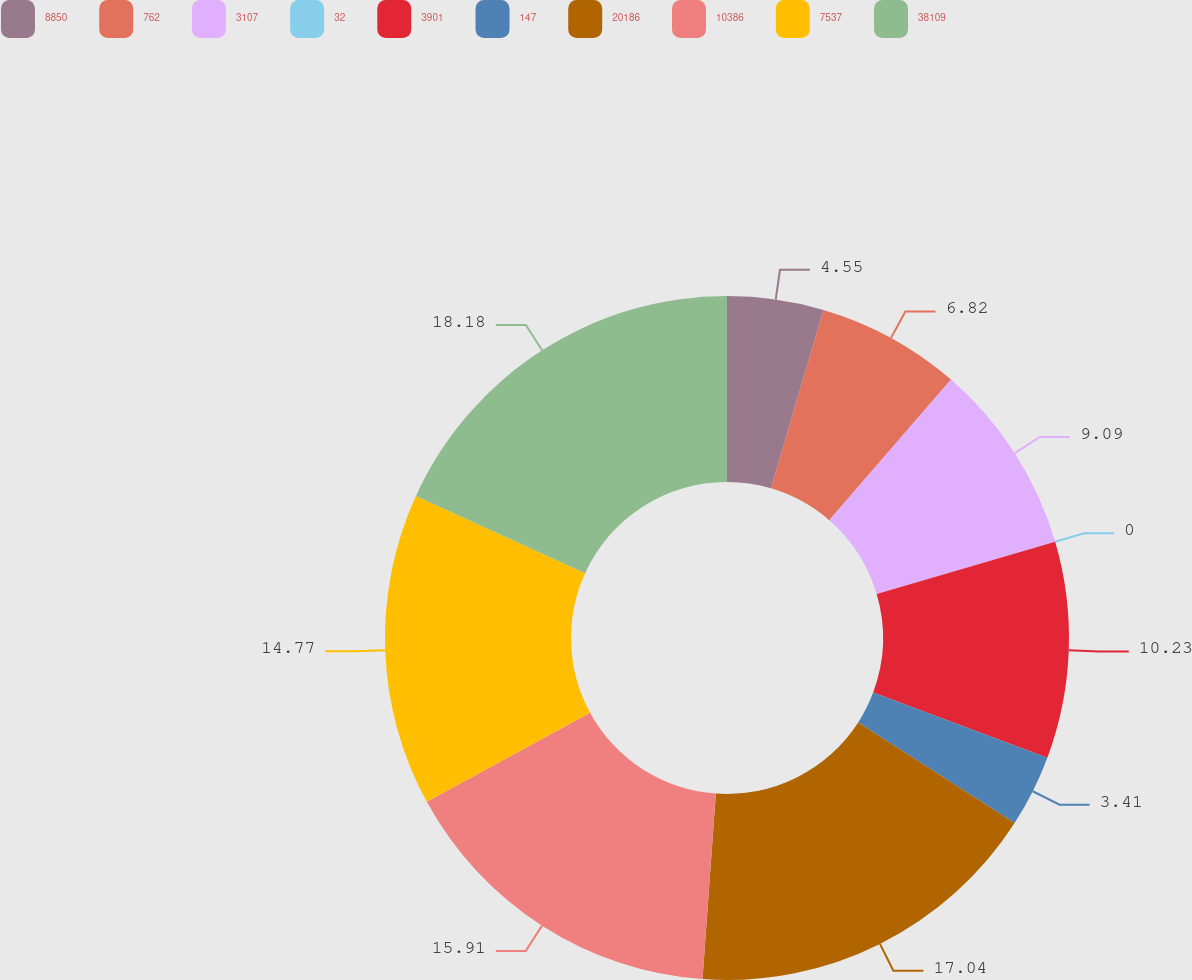Convert chart. <chart><loc_0><loc_0><loc_500><loc_500><pie_chart><fcel>8850<fcel>762<fcel>3107<fcel>32<fcel>3901<fcel>147<fcel>20186<fcel>10386<fcel>7537<fcel>38109<nl><fcel>4.55%<fcel>6.82%<fcel>9.09%<fcel>0.0%<fcel>10.23%<fcel>3.41%<fcel>17.04%<fcel>15.91%<fcel>14.77%<fcel>18.18%<nl></chart> 